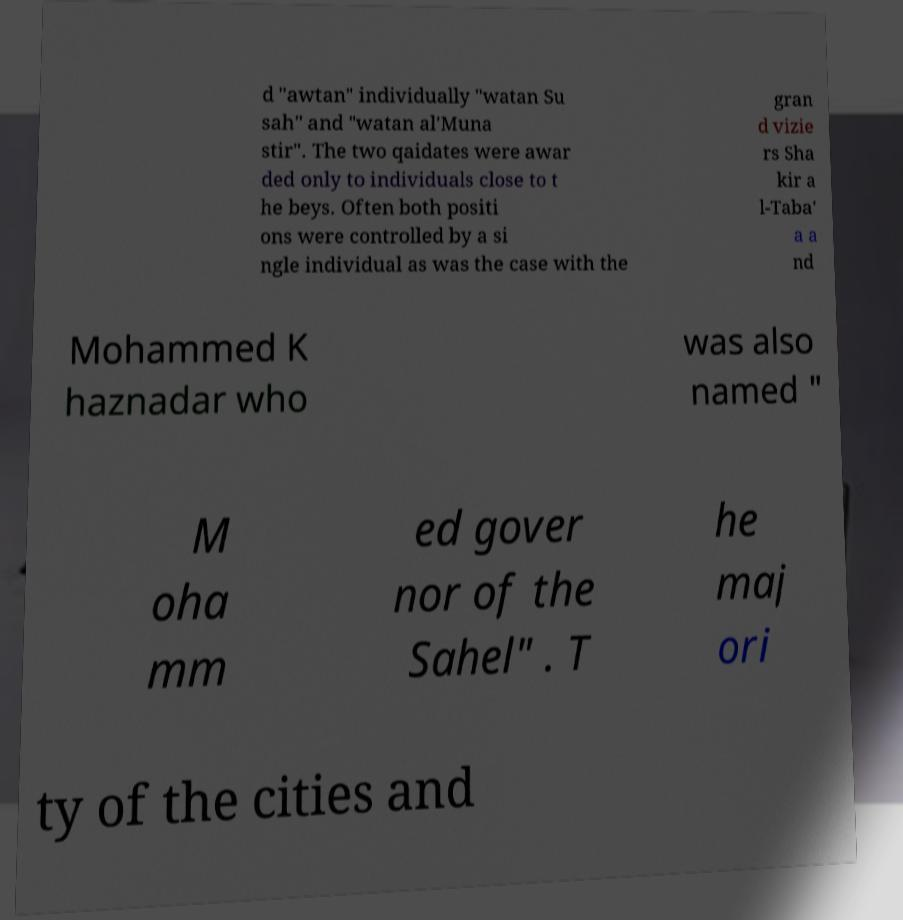Could you extract and type out the text from this image? d "awtan" individually "watan Su sah" and "watan al'Muna stir". The two qaidates were awar ded only to individuals close to t he beys. Often both positi ons were controlled by a si ngle individual as was the case with the gran d vizie rs Sha kir a l-Taba' a a nd Mohammed K haznadar who was also named " M oha mm ed gover nor of the Sahel" . T he maj ori ty of the cities and 